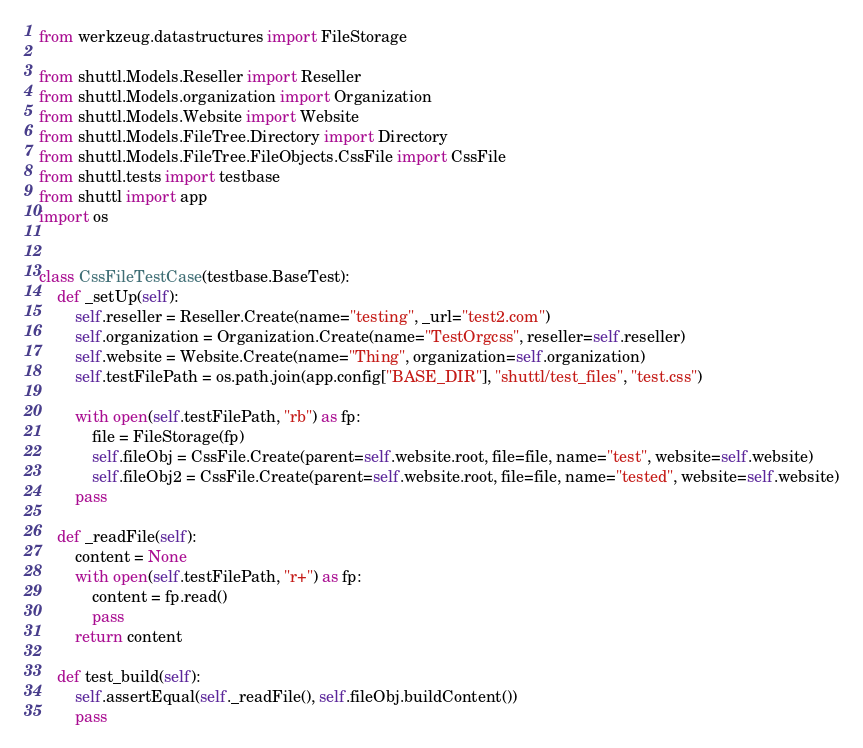Convert code to text. <code><loc_0><loc_0><loc_500><loc_500><_Python_>from werkzeug.datastructures import FileStorage

from shuttl.Models.Reseller import Reseller
from shuttl.Models.organization import Organization
from shuttl.Models.Website import Website
from shuttl.Models.FileTree.Directory import Directory
from shuttl.Models.FileTree.FileObjects.CssFile import CssFile
from shuttl.tests import testbase
from shuttl import app
import os


class CssFileTestCase(testbase.BaseTest):
    def _setUp(self):
        self.reseller = Reseller.Create(name="testing", _url="test2.com")
        self.organization = Organization.Create(name="TestOrgcss", reseller=self.reseller)
        self.website = Website.Create(name="Thing", organization=self.organization)
        self.testFilePath = os.path.join(app.config["BASE_DIR"], "shuttl/test_files", "test.css")

        with open(self.testFilePath, "rb") as fp:
            file = FileStorage(fp)
            self.fileObj = CssFile.Create(parent=self.website.root, file=file, name="test", website=self.website)
            self.fileObj2 = CssFile.Create(parent=self.website.root, file=file, name="tested", website=self.website)
        pass

    def _readFile(self):
        content = None
        with open(self.testFilePath, "r+") as fp:
            content = fp.read()
            pass
        return content

    def test_build(self):
        self.assertEqual(self._readFile(), self.fileObj.buildContent())
        pass
</code> 